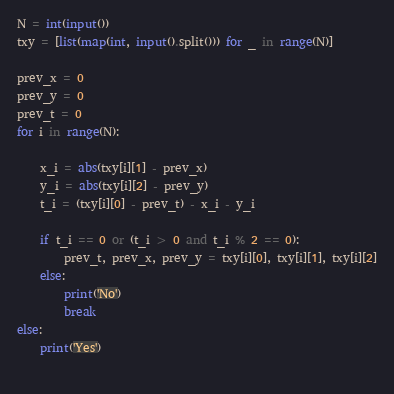<code> <loc_0><loc_0><loc_500><loc_500><_Python_>N = int(input())
txy = [list(map(int, input().split())) for _ in range(N)]

prev_x = 0
prev_y = 0
prev_t = 0
for i in range(N):

    x_i = abs(txy[i][1] - prev_x)
    y_i = abs(txy[i][2] - prev_y)
    t_i = (txy[i][0] - prev_t) - x_i - y_i

    if t_i == 0 or (t_i > 0 and t_i % 2 == 0):
        prev_t, prev_x, prev_y = txy[i][0], txy[i][1], txy[i][2]
    else:
        print('No')
        break
else:
    print('Yes')
        



</code> 